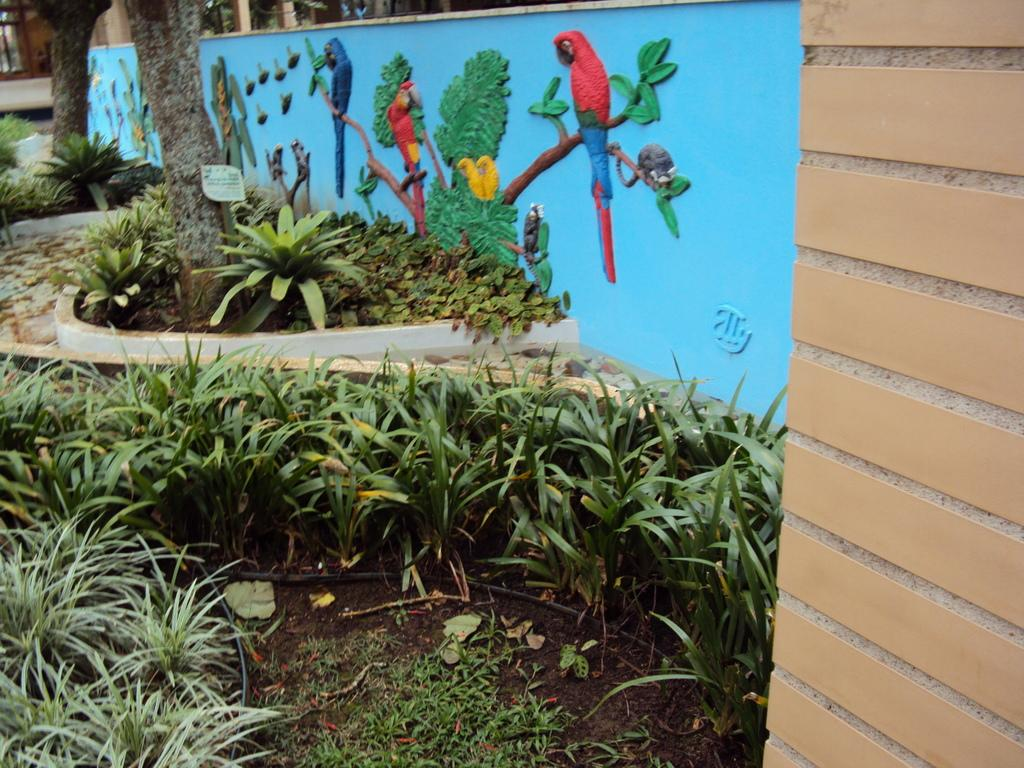What is depicted on the wall in the image? There are sculptures on a wall in the image. What can be seen in the background of the image? There are trees, boards, and bushes in the background of the image. What other objects are present in the image? There are poles in the image. What is visible at the bottom of the image? The ground is visible at the bottom of the image. What is the condition of the cub in the image? There is no cub present in the image. On which channel can the sculptures be seen in the image? The sculptures are visible in the image itself, not on a channel. 